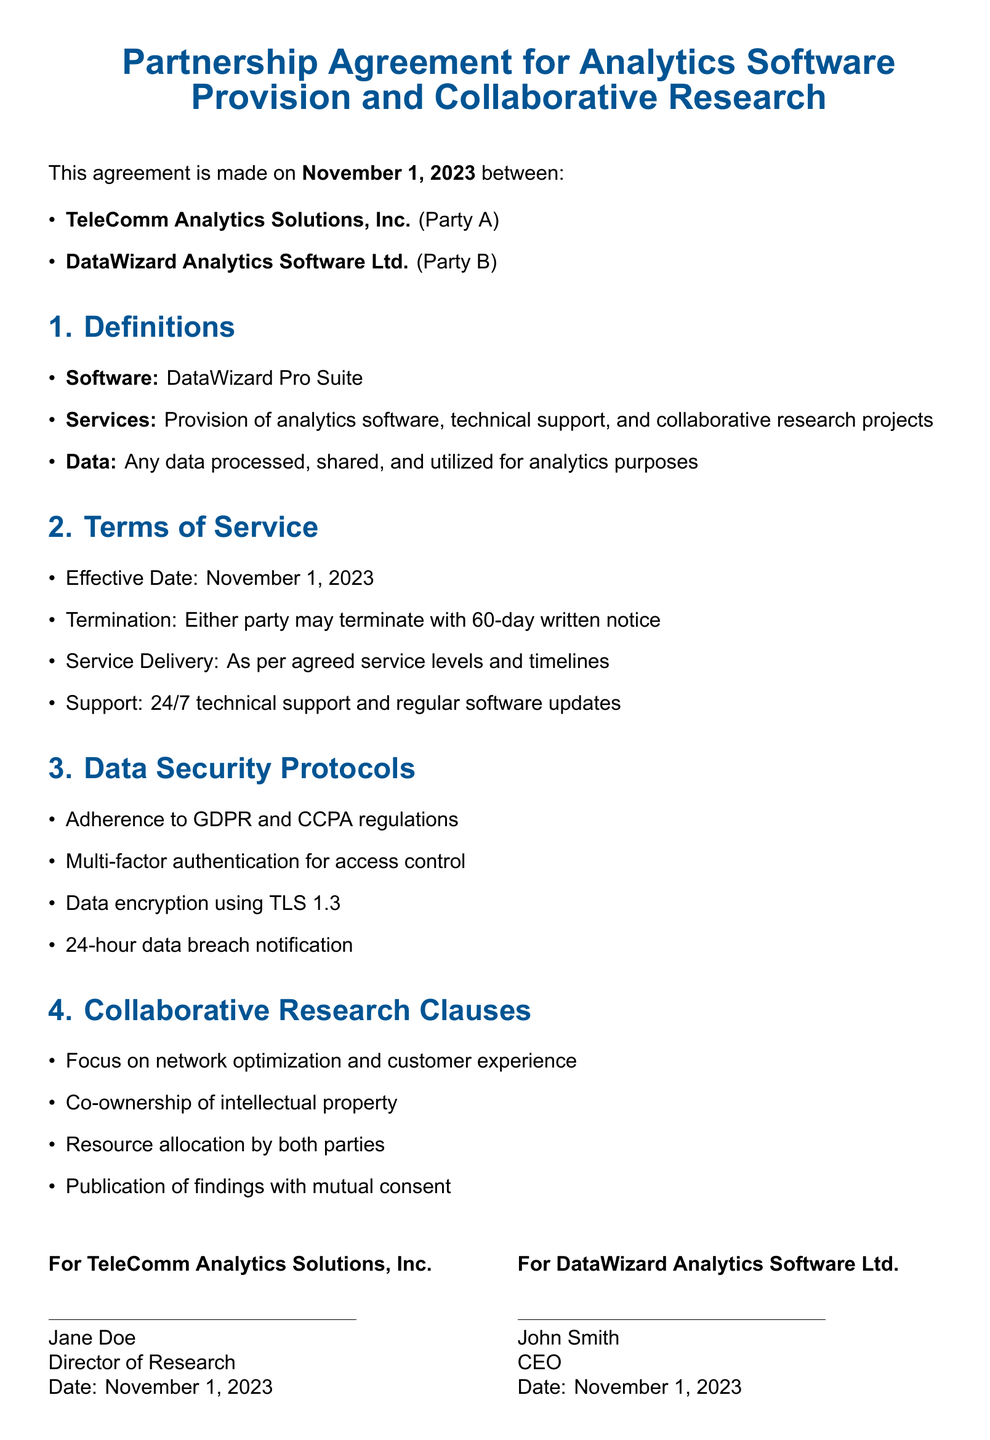what is the effective date of the agreement? The effective date is explicitly mentioned in the document as the commencement of the agreement.
Answer: November 1, 2023 who is the Director of Research for TeleComm Analytics Solutions, Inc.? The document names the individual who holds the title of Director of Research for Party A.
Answer: Jane Doe what is the primary Software mentioned in the agreement? The document specifies the analytics software provided by Party B according to the definitions section.
Answer: DataWizard Pro Suite how many days' notice is required for termination? The document outlines the notice period needed for termination in the terms of service section.
Answer: 60-day what is the data encryption method specified in the data security protocols? The specified encryption method is mentioned as part of the data security measures outlined in the document.
Answer: TLS 1.3 which regulatory frameworks does the agreement adhere to? The document lists the compliance requirements in the data security section, indicating the legal frameworks for data protection.
Answer: GDPR and CCPA which aspect is the focus of the collaborative research? The document clearly states the areas of focus for the collaborative research efforts between both parties.
Answer: network optimization and customer experience who is the CEO of DataWizard Analytics Software Ltd.? The document includes the name and title of the CEO of Party B, confirming their identity as per the signing section.
Answer: John Smith 